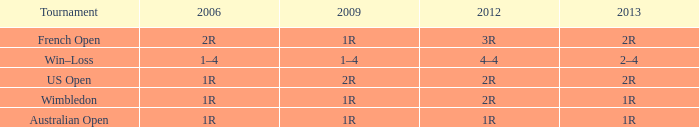What is the Tournament when the 2013 is 1r? Australian Open, Wimbledon. 